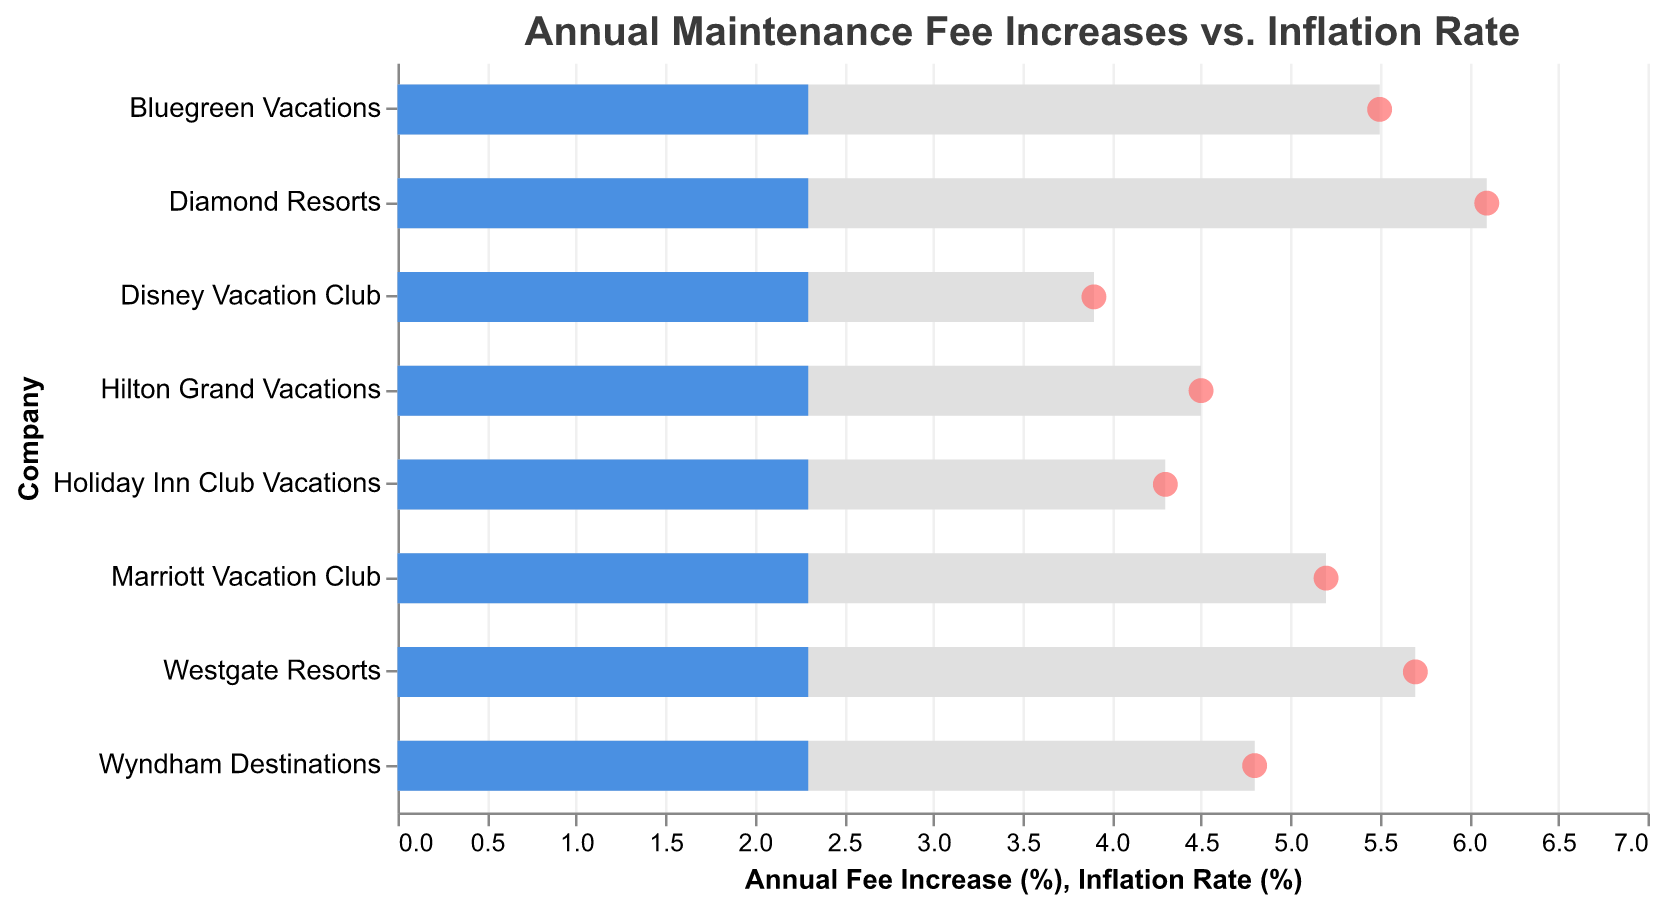Which company has the highest annual fee increase? Diamond Resorts has the highest annual fee increase. This can be seen from the bullet chart where Diamond Resorts' bar extends the furthest to the right on the x-axis labeled "Annual Fee Increase (%)".
Answer: Diamond Resorts How does Marriott Vacation Club's annual fee increase compare to the inflation rate? Marriott Vacation Club's annual fee increase (5.2%) is significantly higher than the inflation rate (2.3%). The bullet chart shows Marriott's bar is much longer than the inflation rate bar, indicating a larger value.
Answer: Higher Which company has the smallest difference between their annual fee increase and the inflation rate? Disney Vacation Club has the smallest difference between their annual fee increase (3.9%) and the inflation rate (2.3%). The difference is calculated as 3.9 - 2.3 = 1.6%, which is the smallest among all companies.
Answer: Disney Vacation Club How many companies have an annual fee increase greater than 5%? To find this, count the number of bars in the chart where the annual fee increase exceeds 5%. These companies are Marriott Vacation Club, Bluegreen Vacations, Diamond Resorts, and Westgate Resorts.
Answer: 4 Compare Holiday Inn Club Vacations’ annual fee increase with Hilton Grand Vacations’ annual fee increase. Holiday Inn Club Vacations has an annual fee increase of 4.3% while Hilton Grand Vacations has an increase of 4.5%. By subtracting the two, we find that Hilton Grand Vacations’ increase is slightly higher by 0.2%.
Answer: Hilton Grand Vacations is higher Which companies have an annual fee increase more than twice the inflation rate? To determine this, check companies where the annual fee increase is more than double the 2.3% inflation rate (i.e., more than 4.6%). These companies are Marriott Vacation Club, Bluegreen Vacations, Diamond Resorts, and Westgate Resorts.
Answer: 4 companies What is the average annual fee increase for all companies? Add up all the annual fee increase percentages and divide by the number of companies: (5.2 + 4.8 + 4.5 + 3.9 + 5.5 + 6.1 + 5.7 + 4.3) / 8 = 40 / 8 = 5%
Answer: 5% Identify the company with the second highest annual fee increase. The second highest annual fee increase is from Westgate Resorts with an increase of 5.7%, just below Diamond Resorts. This can be identified by comparing the length of the bars.
Answer: Westgate Resorts 